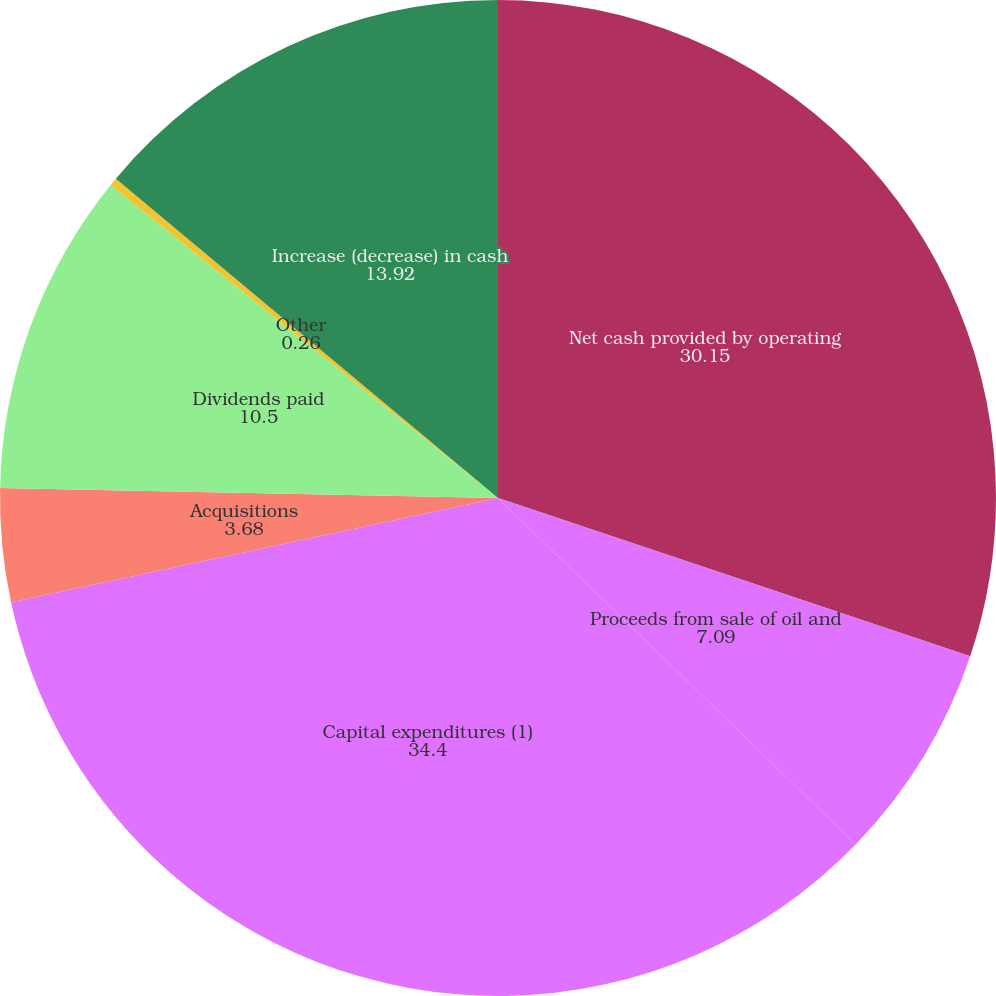Convert chart to OTSL. <chart><loc_0><loc_0><loc_500><loc_500><pie_chart><fcel>Net cash provided by operating<fcel>Proceeds from sale of oil and<fcel>Capital expenditures (1)<fcel>Acquisitions<fcel>Dividends paid<fcel>Other<fcel>Increase (decrease) in cash<nl><fcel>30.15%<fcel>7.09%<fcel>34.4%<fcel>3.68%<fcel>10.5%<fcel>0.26%<fcel>13.92%<nl></chart> 